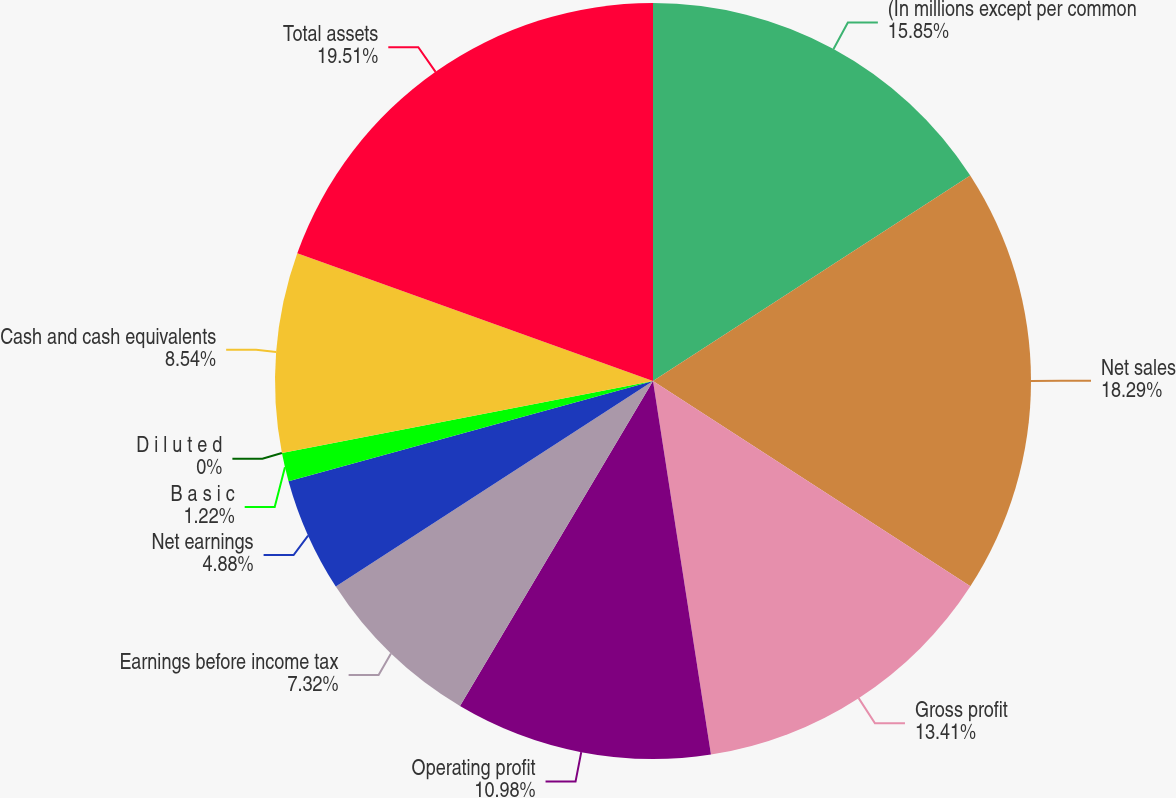Convert chart to OTSL. <chart><loc_0><loc_0><loc_500><loc_500><pie_chart><fcel>(In millions except per common<fcel>Net sales<fcel>Gross profit<fcel>Operating profit<fcel>Earnings before income tax<fcel>Net earnings<fcel>B a s i c<fcel>D i l u t e d<fcel>Cash and cash equivalents<fcel>Total assets<nl><fcel>15.85%<fcel>18.29%<fcel>13.41%<fcel>10.98%<fcel>7.32%<fcel>4.88%<fcel>1.22%<fcel>0.0%<fcel>8.54%<fcel>19.51%<nl></chart> 